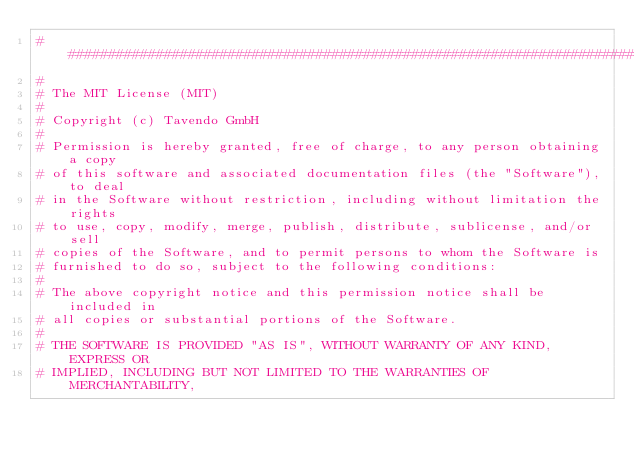<code> <loc_0><loc_0><loc_500><loc_500><_Python_>###############################################################################
#
# The MIT License (MIT)
#
# Copyright (c) Tavendo GmbH
#
# Permission is hereby granted, free of charge, to any person obtaining a copy
# of this software and associated documentation files (the "Software"), to deal
# in the Software without restriction, including without limitation the rights
# to use, copy, modify, merge, publish, distribute, sublicense, and/or sell
# copies of the Software, and to permit persons to whom the Software is
# furnished to do so, subject to the following conditions:
#
# The above copyright notice and this permission notice shall be included in
# all copies or substantial portions of the Software.
#
# THE SOFTWARE IS PROVIDED "AS IS", WITHOUT WARRANTY OF ANY KIND, EXPRESS OR
# IMPLIED, INCLUDING BUT NOT LIMITED TO THE WARRANTIES OF MERCHANTABILITY,</code> 